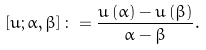<formula> <loc_0><loc_0><loc_500><loc_500>\left [ u ; \alpha , \beta \right ] \colon = \frac { u \left ( \alpha \right ) - u \left ( \beta \right ) } { \alpha - \beta } .</formula> 